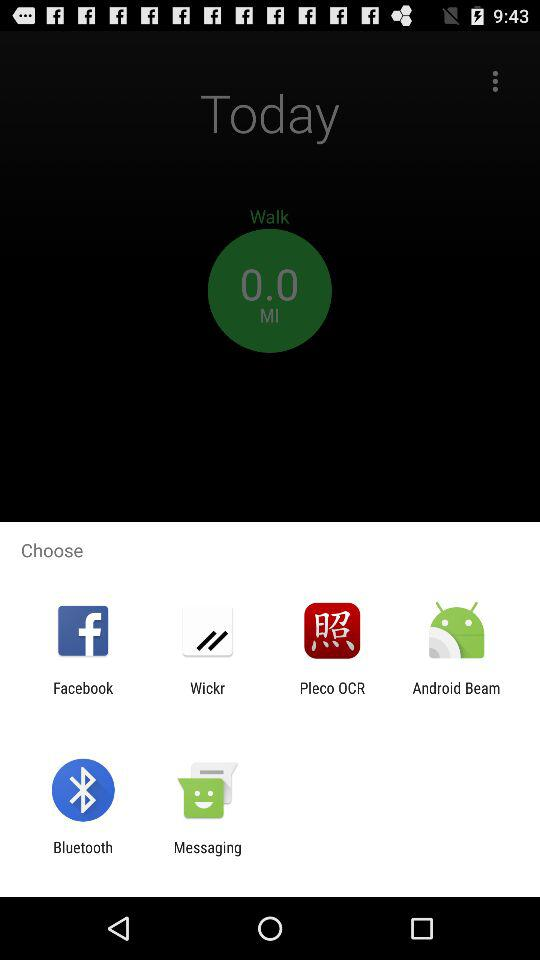What is the time shown in the walk category?
When the provided information is insufficient, respond with <no answer>. <no answer> 